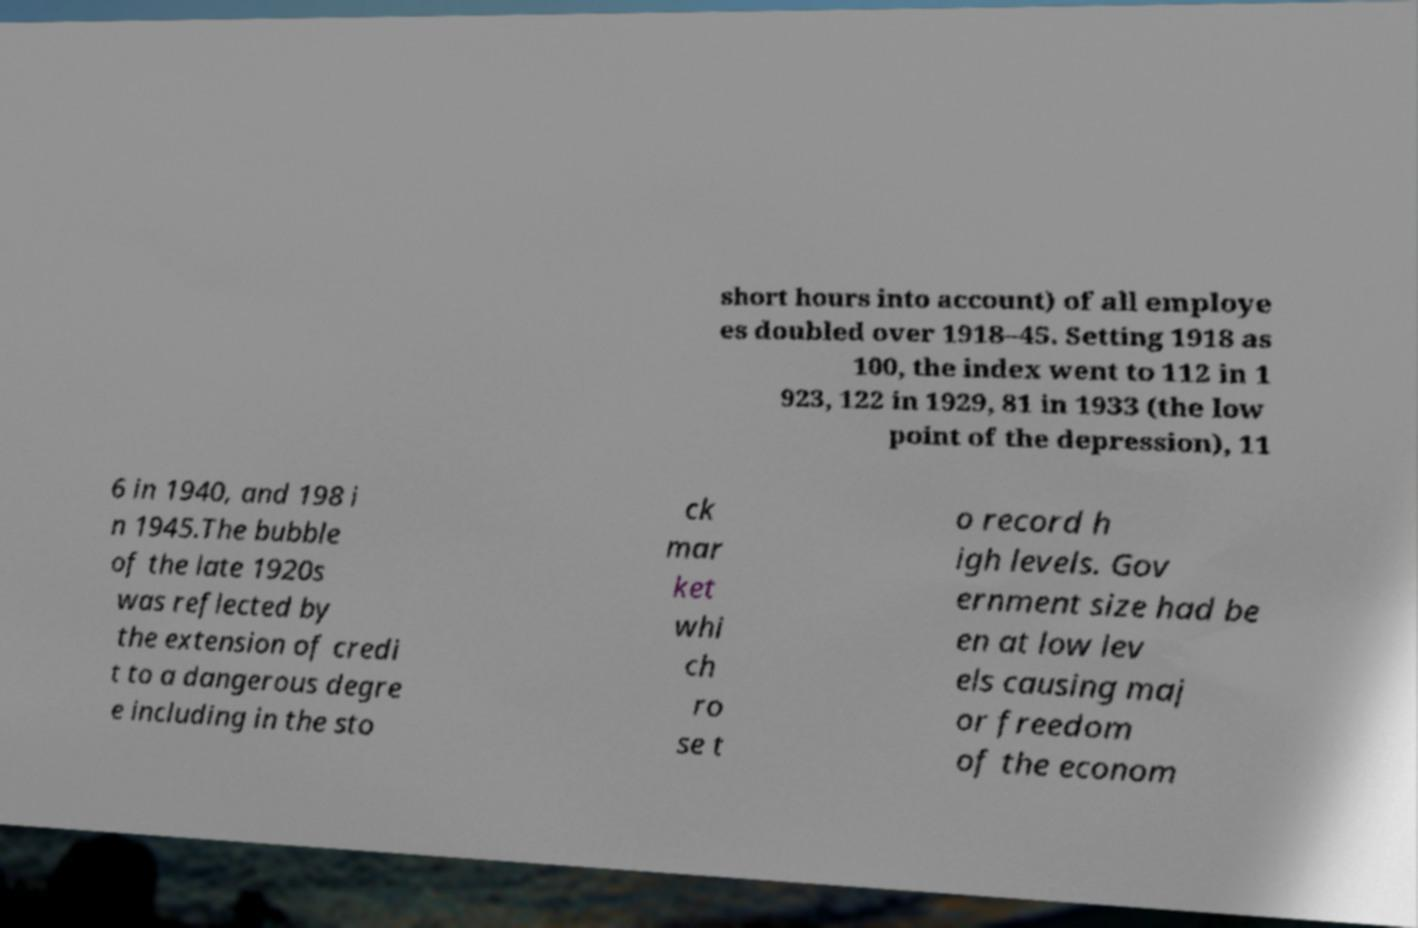What messages or text are displayed in this image? I need them in a readable, typed format. short hours into account) of all employe es doubled over 1918–45. Setting 1918 as 100, the index went to 112 in 1 923, 122 in 1929, 81 in 1933 (the low point of the depression), 11 6 in 1940, and 198 i n 1945.The bubble of the late 1920s was reflected by the extension of credi t to a dangerous degre e including in the sto ck mar ket whi ch ro se t o record h igh levels. Gov ernment size had be en at low lev els causing maj or freedom of the econom 